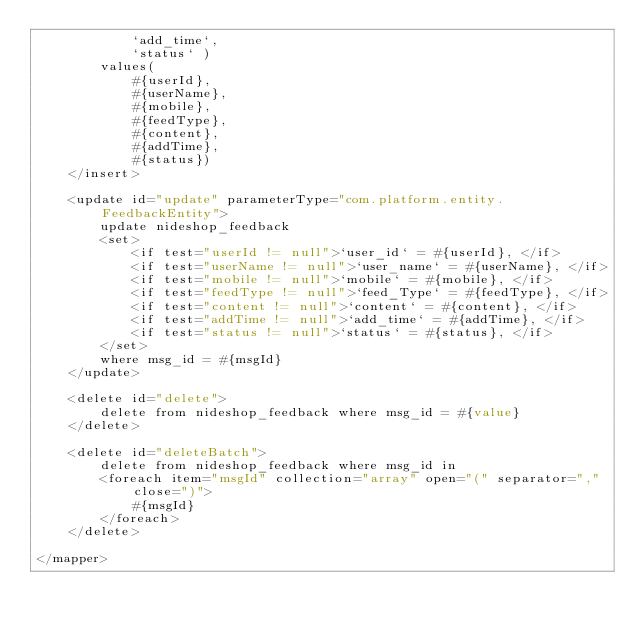<code> <loc_0><loc_0><loc_500><loc_500><_XML_>			`add_time`,
			`status` )
		values(
			#{userId},
			#{userName},
			#{mobile},
			#{feedType},
			#{content},
			#{addTime},
			#{status})
	</insert>
	 
	<update id="update" parameterType="com.platform.entity.FeedbackEntity">
		update nideshop_feedback 
		<set>
			<if test="userId != null">`user_id` = #{userId}, </if>
			<if test="userName != null">`user_name` = #{userName}, </if>
			<if test="mobile != null">`mobile` = #{mobile}, </if>
			<if test="feedType != null">`feed_Type` = #{feedType}, </if>
			<if test="content != null">`content` = #{content}, </if>
			<if test="addTime != null">`add_time` = #{addTime}, </if>
			<if test="status != null">`status` = #{status}, </if>
		</set>
		where msg_id = #{msgId}
	</update>
	
	<delete id="delete">
		delete from nideshop_feedback where msg_id = #{value}
	</delete>
	
	<delete id="deleteBatch">
		delete from nideshop_feedback where msg_id in 
		<foreach item="msgId" collection="array" open="(" separator="," close=")">
			#{msgId}
		</foreach>
	</delete>

</mapper></code> 